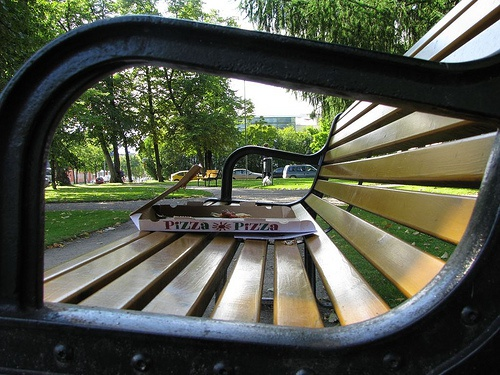Describe the objects in this image and their specific colors. I can see bench in black, gray, darkgray, and white tones, car in black, blue, gray, and white tones, pizza in black, gray, and maroon tones, car in black, gray, darkgray, and darkgreen tones, and car in black, olive, and white tones in this image. 